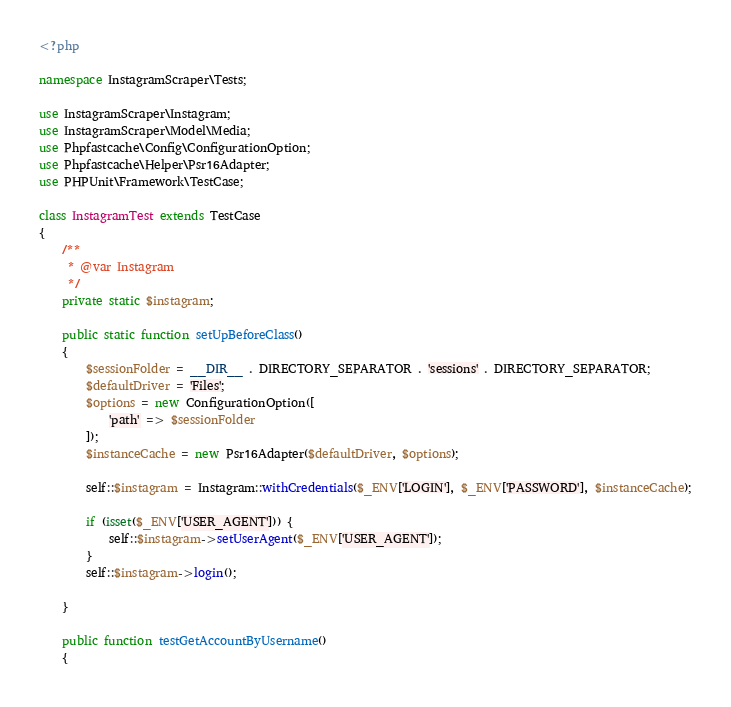Convert code to text. <code><loc_0><loc_0><loc_500><loc_500><_PHP_><?php

namespace InstagramScraper\Tests;

use InstagramScraper\Instagram;
use InstagramScraper\Model\Media;
use Phpfastcache\Config\ConfigurationOption;
use Phpfastcache\Helper\Psr16Adapter;
use PHPUnit\Framework\TestCase;

class InstagramTest extends TestCase
{
    /**
     * @var Instagram
     */
    private static $instagram;

    public static function setUpBeforeClass()
    {
        $sessionFolder = __DIR__ . DIRECTORY_SEPARATOR . 'sessions' . DIRECTORY_SEPARATOR;
        $defaultDriver = 'Files';
        $options = new ConfigurationOption([
            'path' => $sessionFolder
        ]);
        $instanceCache = new Psr16Adapter($defaultDriver, $options);

        self::$instagram = Instagram::withCredentials($_ENV['LOGIN'], $_ENV['PASSWORD'], $instanceCache);

        if (isset($_ENV['USER_AGENT'])) {
            self::$instagram->setUserAgent($_ENV['USER_AGENT']);
        }
        self::$instagram->login();

    }

    public function testGetAccountByUsername()
    {</code> 